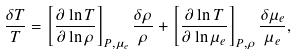Convert formula to latex. <formula><loc_0><loc_0><loc_500><loc_500>\frac { \delta T } { T } = \left [ \frac { \partial \ln T } { \partial \ln \rho } \right ] _ { P , \mu _ { e } } \frac { \delta \rho } { \rho } + \left [ \frac { \partial \ln T } { \partial \ln \mu _ { e } } \right ] _ { P , \rho } \frac { \delta \mu _ { e } } { \mu _ { e } } ,</formula> 